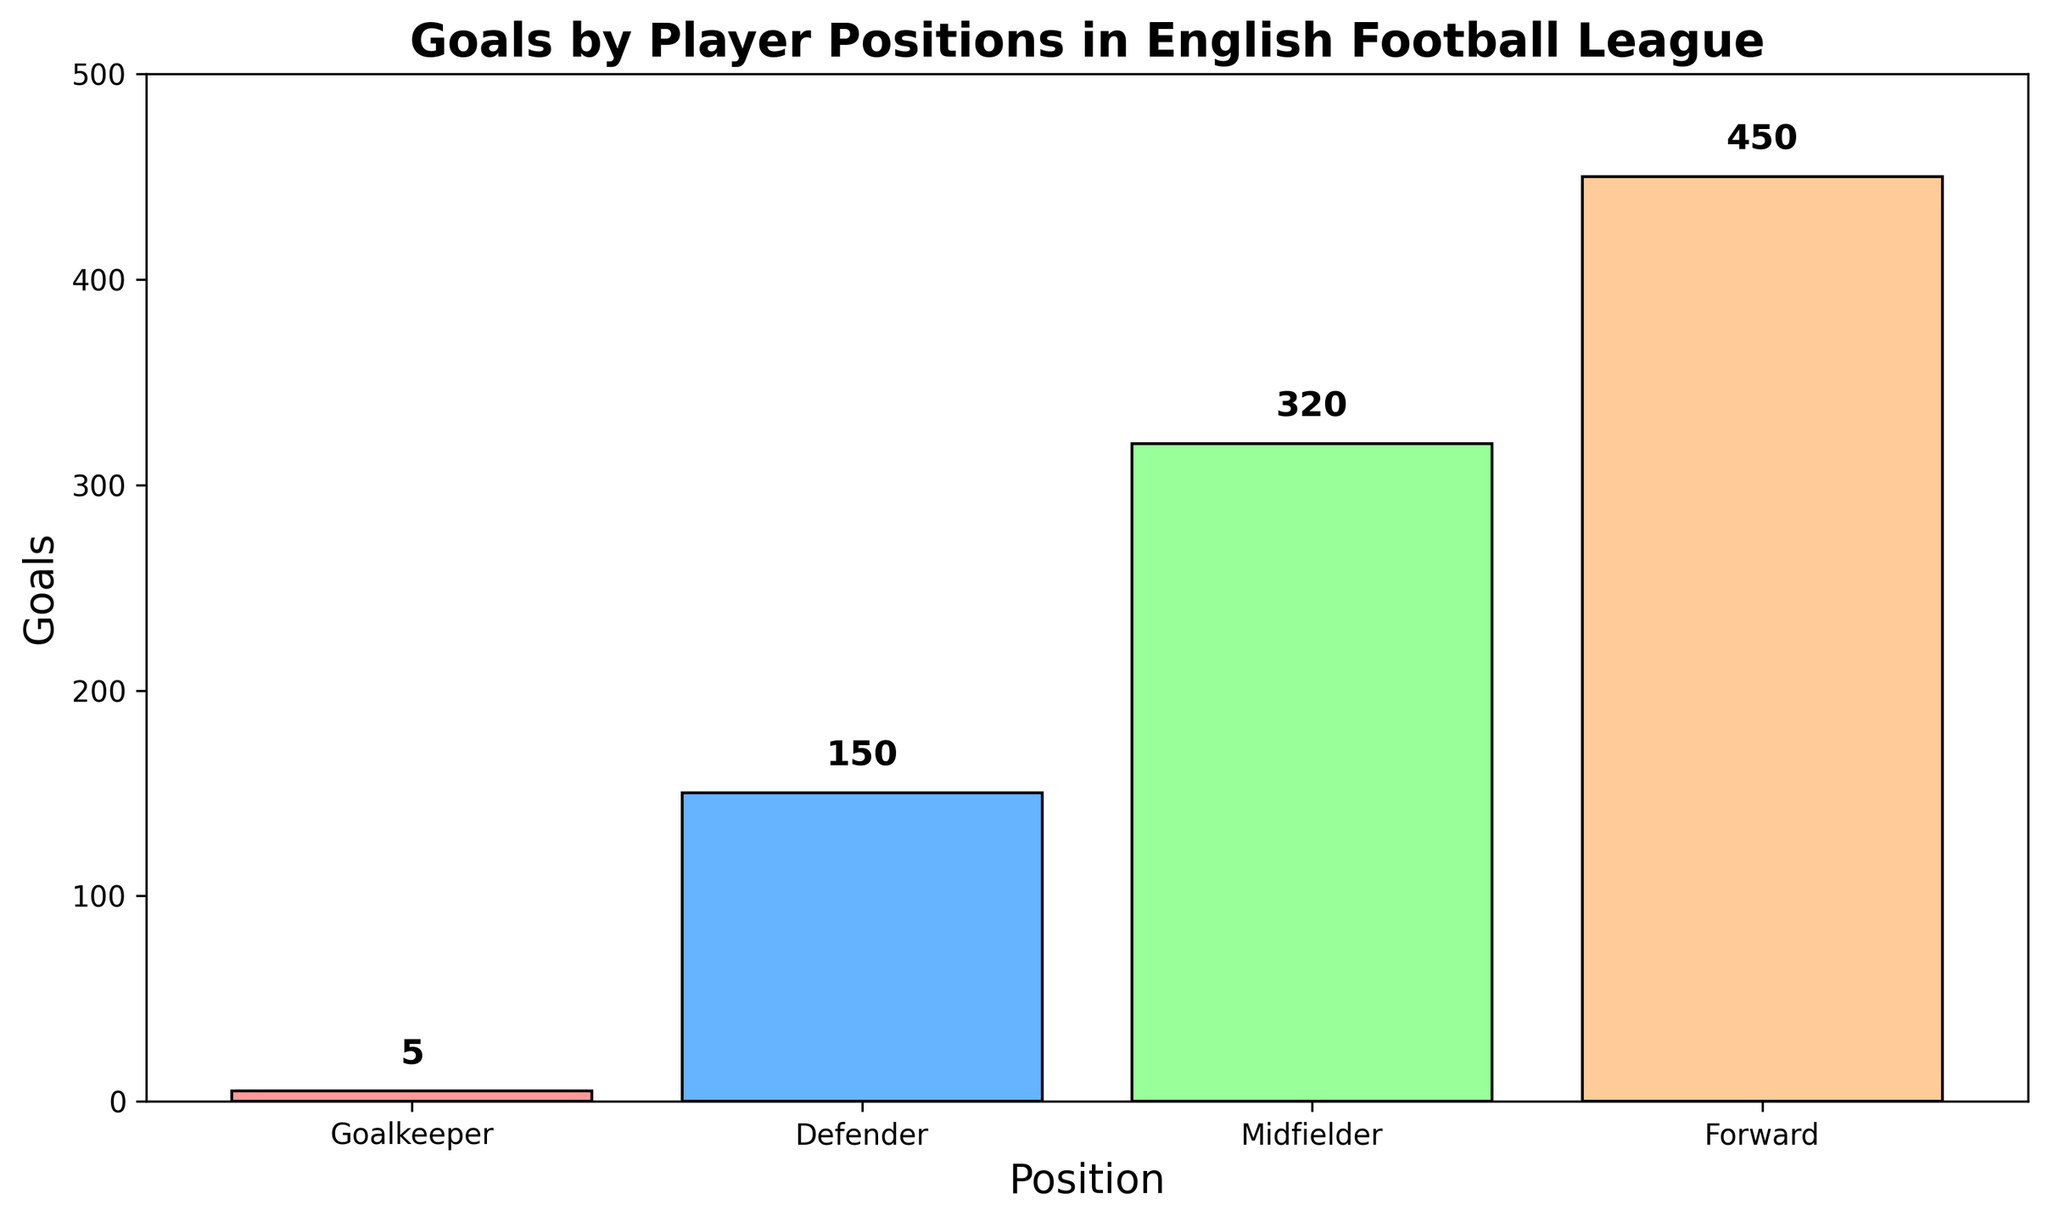Which player position has scored the most goals? By looking at the heights of the bars, we can see that the bar for Forwards is the highest, indicating that Forwards have scored the most goals.
Answer: Forwards How many more goals have been scored by Midfielders compared to Defenders? The bar for Midfielders indicates 320 goals, and the bar for Defenders indicates 150 goals. The difference is 320 - 150 = 170 goals.
Answer: 170 What is the total number of goals scored by all player positions combined? We need to sum the goals from all positions: 5 (Goalkeeper) + 150 (Defender) + 320 (Midfielder) + 450 (Forward) = 925 goals.
Answer: 925 Which player position has the lowest goal count? The bar for Goalkeepers is the shortest, indicating that Goalkeepers have scored the fewest goals.
Answer: Goalkeepers What percentage of the total goals were scored by Forwards? First, find the total number of goals: 925. The number of goals scored by Forwards is 450. The percentage is (450 / 925) * 100 ≈ 48.6%.
Answer: 48.6% What is the difference between the highest and the lowest goal counts? The highest goal count is by Forwards (450) and the lowest by Goalkeepers (5). The difference is 450 - 5 = 445 goals.
Answer: 445 How many goals are scored by Goalkeepers, Defenders, and Midfielders combined? We need to sum the goals from these three positions: 5 (Goalkeeper) + 150 (Defender) + 320 (Midfielder) = 475 goals.
Answer: 475 Compare the number of goals scored by Defenders and Forwards. Which is greater and by how much? Defenders scored 150 goals and Forwards scored 450 goals. Forwards scored more, with a difference of 450 - 150 = 300 goals.
Answer: Forwards by 300 goals Calculate the average goals scored per position. The total goals scored are 925, and there are 4 positions. The average is 925 / 4 = 231.25 goals per position.
Answer: 231.25 Is the number of goals scored by Midfielders more than double the number of goals scored by Defenders? Midfielders scored 320 goals and Defenders scored 150 goals. Double the goals for Defenders is 150 * 2 = 300. Since 320 > 300, Midfielders scored more than double the goals of Defenders.
Answer: Yes 